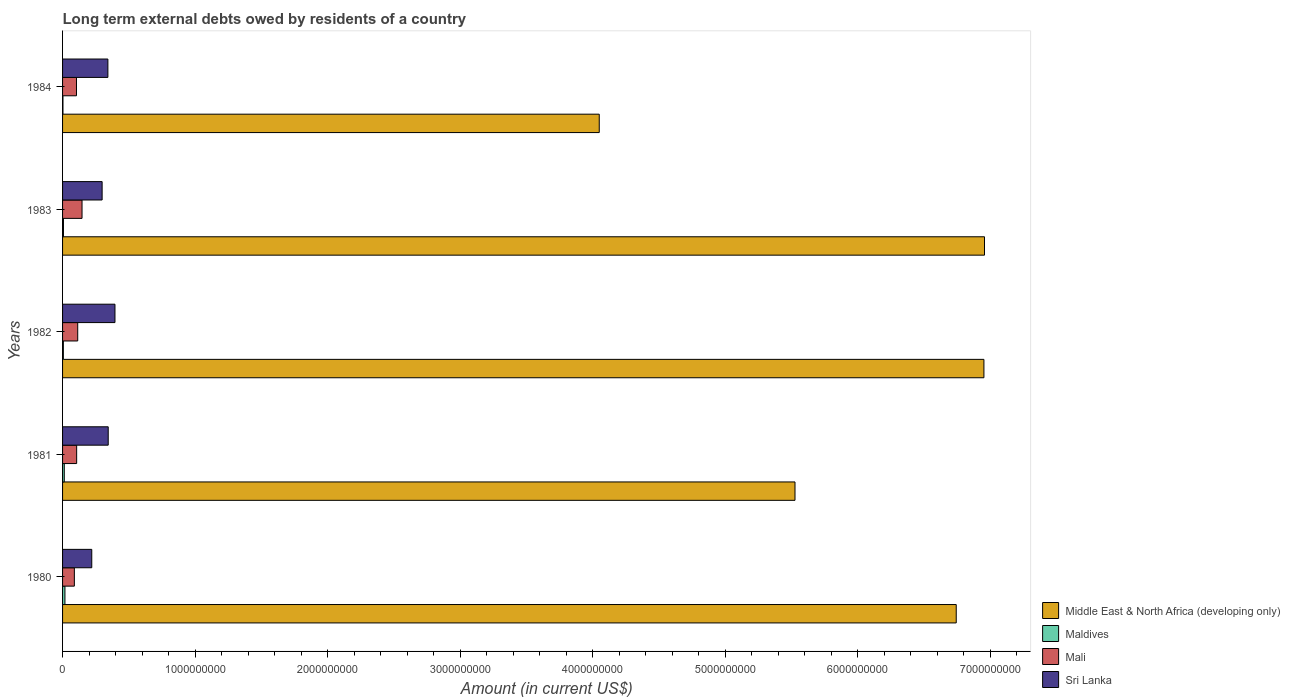How many bars are there on the 3rd tick from the bottom?
Your answer should be compact. 4. What is the label of the 3rd group of bars from the top?
Make the answer very short. 1982. What is the amount of long-term external debts owed by residents in Middle East & North Africa (developing only) in 1982?
Your response must be concise. 6.95e+09. Across all years, what is the maximum amount of long-term external debts owed by residents in Mali?
Offer a very short reply. 1.47e+08. Across all years, what is the minimum amount of long-term external debts owed by residents in Mali?
Provide a succinct answer. 8.90e+07. In which year was the amount of long-term external debts owed by residents in Sri Lanka minimum?
Your response must be concise. 1980. What is the total amount of long-term external debts owed by residents in Middle East & North Africa (developing only) in the graph?
Make the answer very short. 3.02e+1. What is the difference between the amount of long-term external debts owed by residents in Mali in 1982 and that in 1984?
Offer a terse response. 9.27e+06. What is the difference between the amount of long-term external debts owed by residents in Maldives in 1981 and the amount of long-term external debts owed by residents in Middle East & North Africa (developing only) in 1980?
Offer a very short reply. -6.73e+09. What is the average amount of long-term external debts owed by residents in Middle East & North Africa (developing only) per year?
Provide a short and direct response. 6.05e+09. In the year 1983, what is the difference between the amount of long-term external debts owed by residents in Middle East & North Africa (developing only) and amount of long-term external debts owed by residents in Maldives?
Offer a terse response. 6.95e+09. In how many years, is the amount of long-term external debts owed by residents in Sri Lanka greater than 1000000000 US$?
Give a very brief answer. 0. What is the ratio of the amount of long-term external debts owed by residents in Mali in 1980 to that in 1981?
Your answer should be very brief. 0.84. Is the difference between the amount of long-term external debts owed by residents in Middle East & North Africa (developing only) in 1980 and 1981 greater than the difference between the amount of long-term external debts owed by residents in Maldives in 1980 and 1981?
Make the answer very short. Yes. What is the difference between the highest and the second highest amount of long-term external debts owed by residents in Sri Lanka?
Provide a short and direct response. 5.09e+07. What is the difference between the highest and the lowest amount of long-term external debts owed by residents in Middle East & North Africa (developing only)?
Offer a terse response. 2.91e+09. What does the 4th bar from the top in 1983 represents?
Give a very brief answer. Middle East & North Africa (developing only). What does the 3rd bar from the bottom in 1980 represents?
Offer a very short reply. Mali. Is it the case that in every year, the sum of the amount of long-term external debts owed by residents in Middle East & North Africa (developing only) and amount of long-term external debts owed by residents in Mali is greater than the amount of long-term external debts owed by residents in Sri Lanka?
Provide a succinct answer. Yes. Does the graph contain any zero values?
Provide a succinct answer. No. Does the graph contain grids?
Provide a short and direct response. No. Where does the legend appear in the graph?
Make the answer very short. Bottom right. How many legend labels are there?
Give a very brief answer. 4. What is the title of the graph?
Your answer should be compact. Long term external debts owed by residents of a country. What is the label or title of the X-axis?
Your response must be concise. Amount (in current US$). What is the label or title of the Y-axis?
Your answer should be very brief. Years. What is the Amount (in current US$) in Middle East & North Africa (developing only) in 1980?
Make the answer very short. 6.74e+09. What is the Amount (in current US$) of Maldives in 1980?
Your answer should be very brief. 1.79e+07. What is the Amount (in current US$) in Mali in 1980?
Give a very brief answer. 8.90e+07. What is the Amount (in current US$) in Sri Lanka in 1980?
Provide a short and direct response. 2.20e+08. What is the Amount (in current US$) in Middle East & North Africa (developing only) in 1981?
Keep it short and to the point. 5.53e+09. What is the Amount (in current US$) in Maldives in 1981?
Give a very brief answer. 1.29e+07. What is the Amount (in current US$) in Mali in 1981?
Your answer should be compact. 1.06e+08. What is the Amount (in current US$) in Sri Lanka in 1981?
Ensure brevity in your answer.  3.45e+08. What is the Amount (in current US$) in Middle East & North Africa (developing only) in 1982?
Your answer should be very brief. 6.95e+09. What is the Amount (in current US$) of Maldives in 1982?
Your answer should be very brief. 5.96e+06. What is the Amount (in current US$) of Mali in 1982?
Give a very brief answer. 1.14e+08. What is the Amount (in current US$) of Sri Lanka in 1982?
Offer a terse response. 3.95e+08. What is the Amount (in current US$) of Middle East & North Africa (developing only) in 1983?
Offer a terse response. 6.96e+09. What is the Amount (in current US$) of Maldives in 1983?
Offer a terse response. 6.84e+06. What is the Amount (in current US$) of Mali in 1983?
Provide a succinct answer. 1.47e+08. What is the Amount (in current US$) in Sri Lanka in 1983?
Offer a terse response. 2.99e+08. What is the Amount (in current US$) in Middle East & North Africa (developing only) in 1984?
Your answer should be very brief. 4.05e+09. What is the Amount (in current US$) of Maldives in 1984?
Give a very brief answer. 2.90e+06. What is the Amount (in current US$) of Mali in 1984?
Your answer should be very brief. 1.05e+08. What is the Amount (in current US$) in Sri Lanka in 1984?
Offer a terse response. 3.42e+08. Across all years, what is the maximum Amount (in current US$) of Middle East & North Africa (developing only)?
Give a very brief answer. 6.96e+09. Across all years, what is the maximum Amount (in current US$) of Maldives?
Give a very brief answer. 1.79e+07. Across all years, what is the maximum Amount (in current US$) of Mali?
Offer a terse response. 1.47e+08. Across all years, what is the maximum Amount (in current US$) of Sri Lanka?
Offer a terse response. 3.95e+08. Across all years, what is the minimum Amount (in current US$) in Middle East & North Africa (developing only)?
Offer a very short reply. 4.05e+09. Across all years, what is the minimum Amount (in current US$) of Maldives?
Your response must be concise. 2.90e+06. Across all years, what is the minimum Amount (in current US$) in Mali?
Offer a terse response. 8.90e+07. Across all years, what is the minimum Amount (in current US$) of Sri Lanka?
Your response must be concise. 2.20e+08. What is the total Amount (in current US$) in Middle East & North Africa (developing only) in the graph?
Ensure brevity in your answer.  3.02e+1. What is the total Amount (in current US$) in Maldives in the graph?
Keep it short and to the point. 4.65e+07. What is the total Amount (in current US$) of Mali in the graph?
Offer a very short reply. 5.62e+08. What is the total Amount (in current US$) in Sri Lanka in the graph?
Provide a succinct answer. 1.60e+09. What is the difference between the Amount (in current US$) of Middle East & North Africa (developing only) in 1980 and that in 1981?
Offer a terse response. 1.22e+09. What is the difference between the Amount (in current US$) in Maldives in 1980 and that in 1981?
Offer a terse response. 4.98e+06. What is the difference between the Amount (in current US$) in Mali in 1980 and that in 1981?
Provide a succinct answer. -1.74e+07. What is the difference between the Amount (in current US$) of Sri Lanka in 1980 and that in 1981?
Your response must be concise. -1.24e+08. What is the difference between the Amount (in current US$) of Middle East & North Africa (developing only) in 1980 and that in 1982?
Keep it short and to the point. -2.09e+08. What is the difference between the Amount (in current US$) in Maldives in 1980 and that in 1982?
Provide a succinct answer. 1.19e+07. What is the difference between the Amount (in current US$) of Mali in 1980 and that in 1982?
Provide a short and direct response. -2.53e+07. What is the difference between the Amount (in current US$) of Sri Lanka in 1980 and that in 1982?
Provide a short and direct response. -1.75e+08. What is the difference between the Amount (in current US$) of Middle East & North Africa (developing only) in 1980 and that in 1983?
Keep it short and to the point. -2.13e+08. What is the difference between the Amount (in current US$) of Maldives in 1980 and that in 1983?
Give a very brief answer. 1.11e+07. What is the difference between the Amount (in current US$) in Mali in 1980 and that in 1983?
Give a very brief answer. -5.79e+07. What is the difference between the Amount (in current US$) in Sri Lanka in 1980 and that in 1983?
Provide a short and direct response. -7.82e+07. What is the difference between the Amount (in current US$) of Middle East & North Africa (developing only) in 1980 and that in 1984?
Your answer should be very brief. 2.69e+09. What is the difference between the Amount (in current US$) of Maldives in 1980 and that in 1984?
Provide a short and direct response. 1.50e+07. What is the difference between the Amount (in current US$) in Mali in 1980 and that in 1984?
Offer a terse response. -1.60e+07. What is the difference between the Amount (in current US$) of Sri Lanka in 1980 and that in 1984?
Make the answer very short. -1.22e+08. What is the difference between the Amount (in current US$) in Middle East & North Africa (developing only) in 1981 and that in 1982?
Offer a very short reply. -1.43e+09. What is the difference between the Amount (in current US$) of Maldives in 1981 and that in 1982?
Offer a very short reply. 6.96e+06. What is the difference between the Amount (in current US$) in Mali in 1981 and that in 1982?
Offer a very short reply. -7.94e+06. What is the difference between the Amount (in current US$) of Sri Lanka in 1981 and that in 1982?
Your answer should be very brief. -5.09e+07. What is the difference between the Amount (in current US$) of Middle East & North Africa (developing only) in 1981 and that in 1983?
Keep it short and to the point. -1.43e+09. What is the difference between the Amount (in current US$) of Maldives in 1981 and that in 1983?
Offer a terse response. 6.07e+06. What is the difference between the Amount (in current US$) in Mali in 1981 and that in 1983?
Keep it short and to the point. -4.05e+07. What is the difference between the Amount (in current US$) in Sri Lanka in 1981 and that in 1983?
Provide a short and direct response. 4.60e+07. What is the difference between the Amount (in current US$) of Middle East & North Africa (developing only) in 1981 and that in 1984?
Provide a succinct answer. 1.48e+09. What is the difference between the Amount (in current US$) of Maldives in 1981 and that in 1984?
Offer a very short reply. 1.00e+07. What is the difference between the Amount (in current US$) of Mali in 1981 and that in 1984?
Give a very brief answer. 1.33e+06. What is the difference between the Amount (in current US$) of Sri Lanka in 1981 and that in 1984?
Give a very brief answer. 2.56e+06. What is the difference between the Amount (in current US$) in Middle East & North Africa (developing only) in 1982 and that in 1983?
Give a very brief answer. -4.38e+06. What is the difference between the Amount (in current US$) in Maldives in 1982 and that in 1983?
Your answer should be compact. -8.90e+05. What is the difference between the Amount (in current US$) of Mali in 1982 and that in 1983?
Offer a very short reply. -3.26e+07. What is the difference between the Amount (in current US$) in Sri Lanka in 1982 and that in 1983?
Your answer should be compact. 9.69e+07. What is the difference between the Amount (in current US$) in Middle East & North Africa (developing only) in 1982 and that in 1984?
Your answer should be compact. 2.90e+09. What is the difference between the Amount (in current US$) of Maldives in 1982 and that in 1984?
Give a very brief answer. 3.05e+06. What is the difference between the Amount (in current US$) in Mali in 1982 and that in 1984?
Keep it short and to the point. 9.27e+06. What is the difference between the Amount (in current US$) of Sri Lanka in 1982 and that in 1984?
Your answer should be very brief. 5.35e+07. What is the difference between the Amount (in current US$) in Middle East & North Africa (developing only) in 1983 and that in 1984?
Your answer should be very brief. 2.91e+09. What is the difference between the Amount (in current US$) of Maldives in 1983 and that in 1984?
Your answer should be compact. 3.94e+06. What is the difference between the Amount (in current US$) of Mali in 1983 and that in 1984?
Your answer should be compact. 4.19e+07. What is the difference between the Amount (in current US$) of Sri Lanka in 1983 and that in 1984?
Provide a succinct answer. -4.34e+07. What is the difference between the Amount (in current US$) in Middle East & North Africa (developing only) in 1980 and the Amount (in current US$) in Maldives in 1981?
Ensure brevity in your answer.  6.73e+09. What is the difference between the Amount (in current US$) in Middle East & North Africa (developing only) in 1980 and the Amount (in current US$) in Mali in 1981?
Give a very brief answer. 6.64e+09. What is the difference between the Amount (in current US$) in Middle East & North Africa (developing only) in 1980 and the Amount (in current US$) in Sri Lanka in 1981?
Offer a terse response. 6.40e+09. What is the difference between the Amount (in current US$) of Maldives in 1980 and the Amount (in current US$) of Mali in 1981?
Keep it short and to the point. -8.85e+07. What is the difference between the Amount (in current US$) of Maldives in 1980 and the Amount (in current US$) of Sri Lanka in 1981?
Ensure brevity in your answer.  -3.27e+08. What is the difference between the Amount (in current US$) of Mali in 1980 and the Amount (in current US$) of Sri Lanka in 1981?
Make the answer very short. -2.55e+08. What is the difference between the Amount (in current US$) in Middle East & North Africa (developing only) in 1980 and the Amount (in current US$) in Maldives in 1982?
Offer a terse response. 6.74e+09. What is the difference between the Amount (in current US$) of Middle East & North Africa (developing only) in 1980 and the Amount (in current US$) of Mali in 1982?
Provide a short and direct response. 6.63e+09. What is the difference between the Amount (in current US$) of Middle East & North Africa (developing only) in 1980 and the Amount (in current US$) of Sri Lanka in 1982?
Make the answer very short. 6.35e+09. What is the difference between the Amount (in current US$) of Maldives in 1980 and the Amount (in current US$) of Mali in 1982?
Keep it short and to the point. -9.64e+07. What is the difference between the Amount (in current US$) of Maldives in 1980 and the Amount (in current US$) of Sri Lanka in 1982?
Provide a short and direct response. -3.78e+08. What is the difference between the Amount (in current US$) in Mali in 1980 and the Amount (in current US$) in Sri Lanka in 1982?
Ensure brevity in your answer.  -3.06e+08. What is the difference between the Amount (in current US$) in Middle East & North Africa (developing only) in 1980 and the Amount (in current US$) in Maldives in 1983?
Your response must be concise. 6.74e+09. What is the difference between the Amount (in current US$) of Middle East & North Africa (developing only) in 1980 and the Amount (in current US$) of Mali in 1983?
Give a very brief answer. 6.60e+09. What is the difference between the Amount (in current US$) of Middle East & North Africa (developing only) in 1980 and the Amount (in current US$) of Sri Lanka in 1983?
Your response must be concise. 6.45e+09. What is the difference between the Amount (in current US$) in Maldives in 1980 and the Amount (in current US$) in Mali in 1983?
Your answer should be compact. -1.29e+08. What is the difference between the Amount (in current US$) of Maldives in 1980 and the Amount (in current US$) of Sri Lanka in 1983?
Keep it short and to the point. -2.81e+08. What is the difference between the Amount (in current US$) in Mali in 1980 and the Amount (in current US$) in Sri Lanka in 1983?
Keep it short and to the point. -2.09e+08. What is the difference between the Amount (in current US$) in Middle East & North Africa (developing only) in 1980 and the Amount (in current US$) in Maldives in 1984?
Give a very brief answer. 6.74e+09. What is the difference between the Amount (in current US$) in Middle East & North Africa (developing only) in 1980 and the Amount (in current US$) in Mali in 1984?
Ensure brevity in your answer.  6.64e+09. What is the difference between the Amount (in current US$) of Middle East & North Africa (developing only) in 1980 and the Amount (in current US$) of Sri Lanka in 1984?
Provide a succinct answer. 6.40e+09. What is the difference between the Amount (in current US$) of Maldives in 1980 and the Amount (in current US$) of Mali in 1984?
Provide a short and direct response. -8.72e+07. What is the difference between the Amount (in current US$) of Maldives in 1980 and the Amount (in current US$) of Sri Lanka in 1984?
Your answer should be very brief. -3.24e+08. What is the difference between the Amount (in current US$) of Mali in 1980 and the Amount (in current US$) of Sri Lanka in 1984?
Your response must be concise. -2.53e+08. What is the difference between the Amount (in current US$) of Middle East & North Africa (developing only) in 1981 and the Amount (in current US$) of Maldives in 1982?
Keep it short and to the point. 5.52e+09. What is the difference between the Amount (in current US$) in Middle East & North Africa (developing only) in 1981 and the Amount (in current US$) in Mali in 1982?
Keep it short and to the point. 5.41e+09. What is the difference between the Amount (in current US$) of Middle East & North Africa (developing only) in 1981 and the Amount (in current US$) of Sri Lanka in 1982?
Keep it short and to the point. 5.13e+09. What is the difference between the Amount (in current US$) in Maldives in 1981 and the Amount (in current US$) in Mali in 1982?
Offer a terse response. -1.01e+08. What is the difference between the Amount (in current US$) of Maldives in 1981 and the Amount (in current US$) of Sri Lanka in 1982?
Provide a succinct answer. -3.83e+08. What is the difference between the Amount (in current US$) of Mali in 1981 and the Amount (in current US$) of Sri Lanka in 1982?
Provide a succinct answer. -2.89e+08. What is the difference between the Amount (in current US$) of Middle East & North Africa (developing only) in 1981 and the Amount (in current US$) of Maldives in 1983?
Offer a terse response. 5.52e+09. What is the difference between the Amount (in current US$) in Middle East & North Africa (developing only) in 1981 and the Amount (in current US$) in Mali in 1983?
Keep it short and to the point. 5.38e+09. What is the difference between the Amount (in current US$) in Middle East & North Africa (developing only) in 1981 and the Amount (in current US$) in Sri Lanka in 1983?
Keep it short and to the point. 5.23e+09. What is the difference between the Amount (in current US$) in Maldives in 1981 and the Amount (in current US$) in Mali in 1983?
Your answer should be very brief. -1.34e+08. What is the difference between the Amount (in current US$) in Maldives in 1981 and the Amount (in current US$) in Sri Lanka in 1983?
Provide a succinct answer. -2.86e+08. What is the difference between the Amount (in current US$) of Mali in 1981 and the Amount (in current US$) of Sri Lanka in 1983?
Your answer should be very brief. -1.92e+08. What is the difference between the Amount (in current US$) of Middle East & North Africa (developing only) in 1981 and the Amount (in current US$) of Maldives in 1984?
Provide a short and direct response. 5.52e+09. What is the difference between the Amount (in current US$) in Middle East & North Africa (developing only) in 1981 and the Amount (in current US$) in Mali in 1984?
Provide a short and direct response. 5.42e+09. What is the difference between the Amount (in current US$) in Middle East & North Africa (developing only) in 1981 and the Amount (in current US$) in Sri Lanka in 1984?
Your answer should be compact. 5.19e+09. What is the difference between the Amount (in current US$) of Maldives in 1981 and the Amount (in current US$) of Mali in 1984?
Provide a short and direct response. -9.21e+07. What is the difference between the Amount (in current US$) of Maldives in 1981 and the Amount (in current US$) of Sri Lanka in 1984?
Provide a succinct answer. -3.29e+08. What is the difference between the Amount (in current US$) of Mali in 1981 and the Amount (in current US$) of Sri Lanka in 1984?
Keep it short and to the point. -2.36e+08. What is the difference between the Amount (in current US$) in Middle East & North Africa (developing only) in 1982 and the Amount (in current US$) in Maldives in 1983?
Make the answer very short. 6.95e+09. What is the difference between the Amount (in current US$) in Middle East & North Africa (developing only) in 1982 and the Amount (in current US$) in Mali in 1983?
Offer a terse response. 6.81e+09. What is the difference between the Amount (in current US$) in Middle East & North Africa (developing only) in 1982 and the Amount (in current US$) in Sri Lanka in 1983?
Provide a short and direct response. 6.65e+09. What is the difference between the Amount (in current US$) of Maldives in 1982 and the Amount (in current US$) of Mali in 1983?
Give a very brief answer. -1.41e+08. What is the difference between the Amount (in current US$) of Maldives in 1982 and the Amount (in current US$) of Sri Lanka in 1983?
Give a very brief answer. -2.93e+08. What is the difference between the Amount (in current US$) of Mali in 1982 and the Amount (in current US$) of Sri Lanka in 1983?
Give a very brief answer. -1.84e+08. What is the difference between the Amount (in current US$) of Middle East & North Africa (developing only) in 1982 and the Amount (in current US$) of Maldives in 1984?
Keep it short and to the point. 6.95e+09. What is the difference between the Amount (in current US$) of Middle East & North Africa (developing only) in 1982 and the Amount (in current US$) of Mali in 1984?
Give a very brief answer. 6.85e+09. What is the difference between the Amount (in current US$) of Middle East & North Africa (developing only) in 1982 and the Amount (in current US$) of Sri Lanka in 1984?
Your answer should be compact. 6.61e+09. What is the difference between the Amount (in current US$) in Maldives in 1982 and the Amount (in current US$) in Mali in 1984?
Provide a succinct answer. -9.91e+07. What is the difference between the Amount (in current US$) of Maldives in 1982 and the Amount (in current US$) of Sri Lanka in 1984?
Provide a succinct answer. -3.36e+08. What is the difference between the Amount (in current US$) of Mali in 1982 and the Amount (in current US$) of Sri Lanka in 1984?
Keep it short and to the point. -2.28e+08. What is the difference between the Amount (in current US$) of Middle East & North Africa (developing only) in 1983 and the Amount (in current US$) of Maldives in 1984?
Ensure brevity in your answer.  6.95e+09. What is the difference between the Amount (in current US$) in Middle East & North Africa (developing only) in 1983 and the Amount (in current US$) in Mali in 1984?
Make the answer very short. 6.85e+09. What is the difference between the Amount (in current US$) in Middle East & North Africa (developing only) in 1983 and the Amount (in current US$) in Sri Lanka in 1984?
Give a very brief answer. 6.61e+09. What is the difference between the Amount (in current US$) of Maldives in 1983 and the Amount (in current US$) of Mali in 1984?
Ensure brevity in your answer.  -9.82e+07. What is the difference between the Amount (in current US$) in Maldives in 1983 and the Amount (in current US$) in Sri Lanka in 1984?
Make the answer very short. -3.35e+08. What is the difference between the Amount (in current US$) in Mali in 1983 and the Amount (in current US$) in Sri Lanka in 1984?
Ensure brevity in your answer.  -1.95e+08. What is the average Amount (in current US$) in Middle East & North Africa (developing only) per year?
Keep it short and to the point. 6.05e+09. What is the average Amount (in current US$) of Maldives per year?
Offer a terse response. 9.30e+06. What is the average Amount (in current US$) of Mali per year?
Offer a very short reply. 1.12e+08. What is the average Amount (in current US$) in Sri Lanka per year?
Make the answer very short. 3.20e+08. In the year 1980, what is the difference between the Amount (in current US$) of Middle East & North Africa (developing only) and Amount (in current US$) of Maldives?
Your answer should be compact. 6.73e+09. In the year 1980, what is the difference between the Amount (in current US$) of Middle East & North Africa (developing only) and Amount (in current US$) of Mali?
Make the answer very short. 6.65e+09. In the year 1980, what is the difference between the Amount (in current US$) of Middle East & North Africa (developing only) and Amount (in current US$) of Sri Lanka?
Provide a short and direct response. 6.52e+09. In the year 1980, what is the difference between the Amount (in current US$) in Maldives and Amount (in current US$) in Mali?
Keep it short and to the point. -7.11e+07. In the year 1980, what is the difference between the Amount (in current US$) in Maldives and Amount (in current US$) in Sri Lanka?
Offer a very short reply. -2.02e+08. In the year 1980, what is the difference between the Amount (in current US$) of Mali and Amount (in current US$) of Sri Lanka?
Keep it short and to the point. -1.31e+08. In the year 1981, what is the difference between the Amount (in current US$) in Middle East & North Africa (developing only) and Amount (in current US$) in Maldives?
Your answer should be very brief. 5.51e+09. In the year 1981, what is the difference between the Amount (in current US$) in Middle East & North Africa (developing only) and Amount (in current US$) in Mali?
Your response must be concise. 5.42e+09. In the year 1981, what is the difference between the Amount (in current US$) of Middle East & North Africa (developing only) and Amount (in current US$) of Sri Lanka?
Provide a short and direct response. 5.18e+09. In the year 1981, what is the difference between the Amount (in current US$) of Maldives and Amount (in current US$) of Mali?
Offer a terse response. -9.35e+07. In the year 1981, what is the difference between the Amount (in current US$) of Maldives and Amount (in current US$) of Sri Lanka?
Offer a very short reply. -3.32e+08. In the year 1981, what is the difference between the Amount (in current US$) in Mali and Amount (in current US$) in Sri Lanka?
Your answer should be very brief. -2.38e+08. In the year 1982, what is the difference between the Amount (in current US$) of Middle East & North Africa (developing only) and Amount (in current US$) of Maldives?
Ensure brevity in your answer.  6.95e+09. In the year 1982, what is the difference between the Amount (in current US$) of Middle East & North Africa (developing only) and Amount (in current US$) of Mali?
Offer a very short reply. 6.84e+09. In the year 1982, what is the difference between the Amount (in current US$) in Middle East & North Africa (developing only) and Amount (in current US$) in Sri Lanka?
Ensure brevity in your answer.  6.56e+09. In the year 1982, what is the difference between the Amount (in current US$) of Maldives and Amount (in current US$) of Mali?
Keep it short and to the point. -1.08e+08. In the year 1982, what is the difference between the Amount (in current US$) in Maldives and Amount (in current US$) in Sri Lanka?
Give a very brief answer. -3.89e+08. In the year 1982, what is the difference between the Amount (in current US$) of Mali and Amount (in current US$) of Sri Lanka?
Provide a succinct answer. -2.81e+08. In the year 1983, what is the difference between the Amount (in current US$) in Middle East & North Africa (developing only) and Amount (in current US$) in Maldives?
Ensure brevity in your answer.  6.95e+09. In the year 1983, what is the difference between the Amount (in current US$) in Middle East & North Africa (developing only) and Amount (in current US$) in Mali?
Provide a succinct answer. 6.81e+09. In the year 1983, what is the difference between the Amount (in current US$) of Middle East & North Africa (developing only) and Amount (in current US$) of Sri Lanka?
Provide a short and direct response. 6.66e+09. In the year 1983, what is the difference between the Amount (in current US$) in Maldives and Amount (in current US$) in Mali?
Your response must be concise. -1.40e+08. In the year 1983, what is the difference between the Amount (in current US$) of Maldives and Amount (in current US$) of Sri Lanka?
Your answer should be very brief. -2.92e+08. In the year 1983, what is the difference between the Amount (in current US$) in Mali and Amount (in current US$) in Sri Lanka?
Ensure brevity in your answer.  -1.52e+08. In the year 1984, what is the difference between the Amount (in current US$) in Middle East & North Africa (developing only) and Amount (in current US$) in Maldives?
Your answer should be compact. 4.05e+09. In the year 1984, what is the difference between the Amount (in current US$) in Middle East & North Africa (developing only) and Amount (in current US$) in Mali?
Your answer should be compact. 3.94e+09. In the year 1984, what is the difference between the Amount (in current US$) of Middle East & North Africa (developing only) and Amount (in current US$) of Sri Lanka?
Keep it short and to the point. 3.71e+09. In the year 1984, what is the difference between the Amount (in current US$) in Maldives and Amount (in current US$) in Mali?
Keep it short and to the point. -1.02e+08. In the year 1984, what is the difference between the Amount (in current US$) in Maldives and Amount (in current US$) in Sri Lanka?
Provide a short and direct response. -3.39e+08. In the year 1984, what is the difference between the Amount (in current US$) of Mali and Amount (in current US$) of Sri Lanka?
Offer a terse response. -2.37e+08. What is the ratio of the Amount (in current US$) in Middle East & North Africa (developing only) in 1980 to that in 1981?
Provide a succinct answer. 1.22. What is the ratio of the Amount (in current US$) in Maldives in 1980 to that in 1981?
Provide a short and direct response. 1.39. What is the ratio of the Amount (in current US$) of Mali in 1980 to that in 1981?
Provide a short and direct response. 0.84. What is the ratio of the Amount (in current US$) in Sri Lanka in 1980 to that in 1981?
Offer a very short reply. 0.64. What is the ratio of the Amount (in current US$) of Middle East & North Africa (developing only) in 1980 to that in 1982?
Provide a short and direct response. 0.97. What is the ratio of the Amount (in current US$) of Maldives in 1980 to that in 1982?
Your answer should be very brief. 3.01. What is the ratio of the Amount (in current US$) in Mali in 1980 to that in 1982?
Give a very brief answer. 0.78. What is the ratio of the Amount (in current US$) of Sri Lanka in 1980 to that in 1982?
Your answer should be very brief. 0.56. What is the ratio of the Amount (in current US$) of Middle East & North Africa (developing only) in 1980 to that in 1983?
Make the answer very short. 0.97. What is the ratio of the Amount (in current US$) in Maldives in 1980 to that in 1983?
Ensure brevity in your answer.  2.61. What is the ratio of the Amount (in current US$) of Mali in 1980 to that in 1983?
Make the answer very short. 0.61. What is the ratio of the Amount (in current US$) in Sri Lanka in 1980 to that in 1983?
Give a very brief answer. 0.74. What is the ratio of the Amount (in current US$) of Middle East & North Africa (developing only) in 1980 to that in 1984?
Offer a very short reply. 1.67. What is the ratio of the Amount (in current US$) of Maldives in 1980 to that in 1984?
Provide a short and direct response. 6.17. What is the ratio of the Amount (in current US$) of Mali in 1980 to that in 1984?
Provide a succinct answer. 0.85. What is the ratio of the Amount (in current US$) of Sri Lanka in 1980 to that in 1984?
Provide a succinct answer. 0.64. What is the ratio of the Amount (in current US$) in Middle East & North Africa (developing only) in 1981 to that in 1982?
Provide a short and direct response. 0.8. What is the ratio of the Amount (in current US$) of Maldives in 1981 to that in 1982?
Provide a succinct answer. 2.17. What is the ratio of the Amount (in current US$) of Mali in 1981 to that in 1982?
Keep it short and to the point. 0.93. What is the ratio of the Amount (in current US$) of Sri Lanka in 1981 to that in 1982?
Provide a succinct answer. 0.87. What is the ratio of the Amount (in current US$) in Middle East & North Africa (developing only) in 1981 to that in 1983?
Your answer should be very brief. 0.79. What is the ratio of the Amount (in current US$) of Maldives in 1981 to that in 1983?
Make the answer very short. 1.89. What is the ratio of the Amount (in current US$) of Mali in 1981 to that in 1983?
Your answer should be compact. 0.72. What is the ratio of the Amount (in current US$) of Sri Lanka in 1981 to that in 1983?
Your answer should be very brief. 1.15. What is the ratio of the Amount (in current US$) of Middle East & North Africa (developing only) in 1981 to that in 1984?
Keep it short and to the point. 1.36. What is the ratio of the Amount (in current US$) of Maldives in 1981 to that in 1984?
Ensure brevity in your answer.  4.45. What is the ratio of the Amount (in current US$) of Mali in 1981 to that in 1984?
Offer a terse response. 1.01. What is the ratio of the Amount (in current US$) of Sri Lanka in 1981 to that in 1984?
Your answer should be very brief. 1.01. What is the ratio of the Amount (in current US$) in Middle East & North Africa (developing only) in 1982 to that in 1983?
Give a very brief answer. 1. What is the ratio of the Amount (in current US$) of Maldives in 1982 to that in 1983?
Provide a succinct answer. 0.87. What is the ratio of the Amount (in current US$) in Mali in 1982 to that in 1983?
Your response must be concise. 0.78. What is the ratio of the Amount (in current US$) of Sri Lanka in 1982 to that in 1983?
Ensure brevity in your answer.  1.32. What is the ratio of the Amount (in current US$) in Middle East & North Africa (developing only) in 1982 to that in 1984?
Your response must be concise. 1.72. What is the ratio of the Amount (in current US$) in Maldives in 1982 to that in 1984?
Your response must be concise. 2.05. What is the ratio of the Amount (in current US$) of Mali in 1982 to that in 1984?
Give a very brief answer. 1.09. What is the ratio of the Amount (in current US$) of Sri Lanka in 1982 to that in 1984?
Offer a terse response. 1.16. What is the ratio of the Amount (in current US$) in Middle East & North Africa (developing only) in 1983 to that in 1984?
Your response must be concise. 1.72. What is the ratio of the Amount (in current US$) in Maldives in 1983 to that in 1984?
Provide a short and direct response. 2.36. What is the ratio of the Amount (in current US$) in Mali in 1983 to that in 1984?
Your answer should be compact. 1.4. What is the ratio of the Amount (in current US$) in Sri Lanka in 1983 to that in 1984?
Provide a short and direct response. 0.87. What is the difference between the highest and the second highest Amount (in current US$) of Middle East & North Africa (developing only)?
Offer a terse response. 4.38e+06. What is the difference between the highest and the second highest Amount (in current US$) of Maldives?
Ensure brevity in your answer.  4.98e+06. What is the difference between the highest and the second highest Amount (in current US$) of Mali?
Provide a succinct answer. 3.26e+07. What is the difference between the highest and the second highest Amount (in current US$) in Sri Lanka?
Your answer should be compact. 5.09e+07. What is the difference between the highest and the lowest Amount (in current US$) of Middle East & North Africa (developing only)?
Keep it short and to the point. 2.91e+09. What is the difference between the highest and the lowest Amount (in current US$) in Maldives?
Offer a terse response. 1.50e+07. What is the difference between the highest and the lowest Amount (in current US$) of Mali?
Your response must be concise. 5.79e+07. What is the difference between the highest and the lowest Amount (in current US$) of Sri Lanka?
Ensure brevity in your answer.  1.75e+08. 